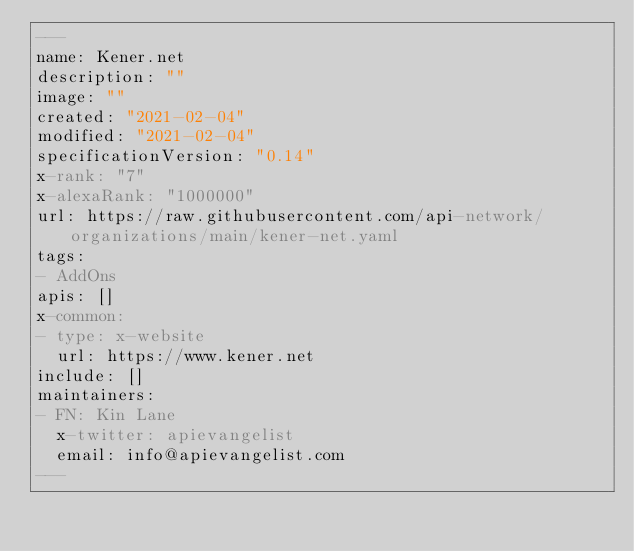<code> <loc_0><loc_0><loc_500><loc_500><_YAML_>---
name: Kener.net
description: ""
image: ""
created: "2021-02-04"
modified: "2021-02-04"
specificationVersion: "0.14"
x-rank: "7"
x-alexaRank: "1000000"
url: https://raw.githubusercontent.com/api-network/organizations/main/kener-net.yaml
tags:
- AddOns
apis: []
x-common:
- type: x-website
  url: https://www.kener.net
include: []
maintainers:
- FN: Kin Lane
  x-twitter: apievangelist
  email: info@apievangelist.com
---</code> 